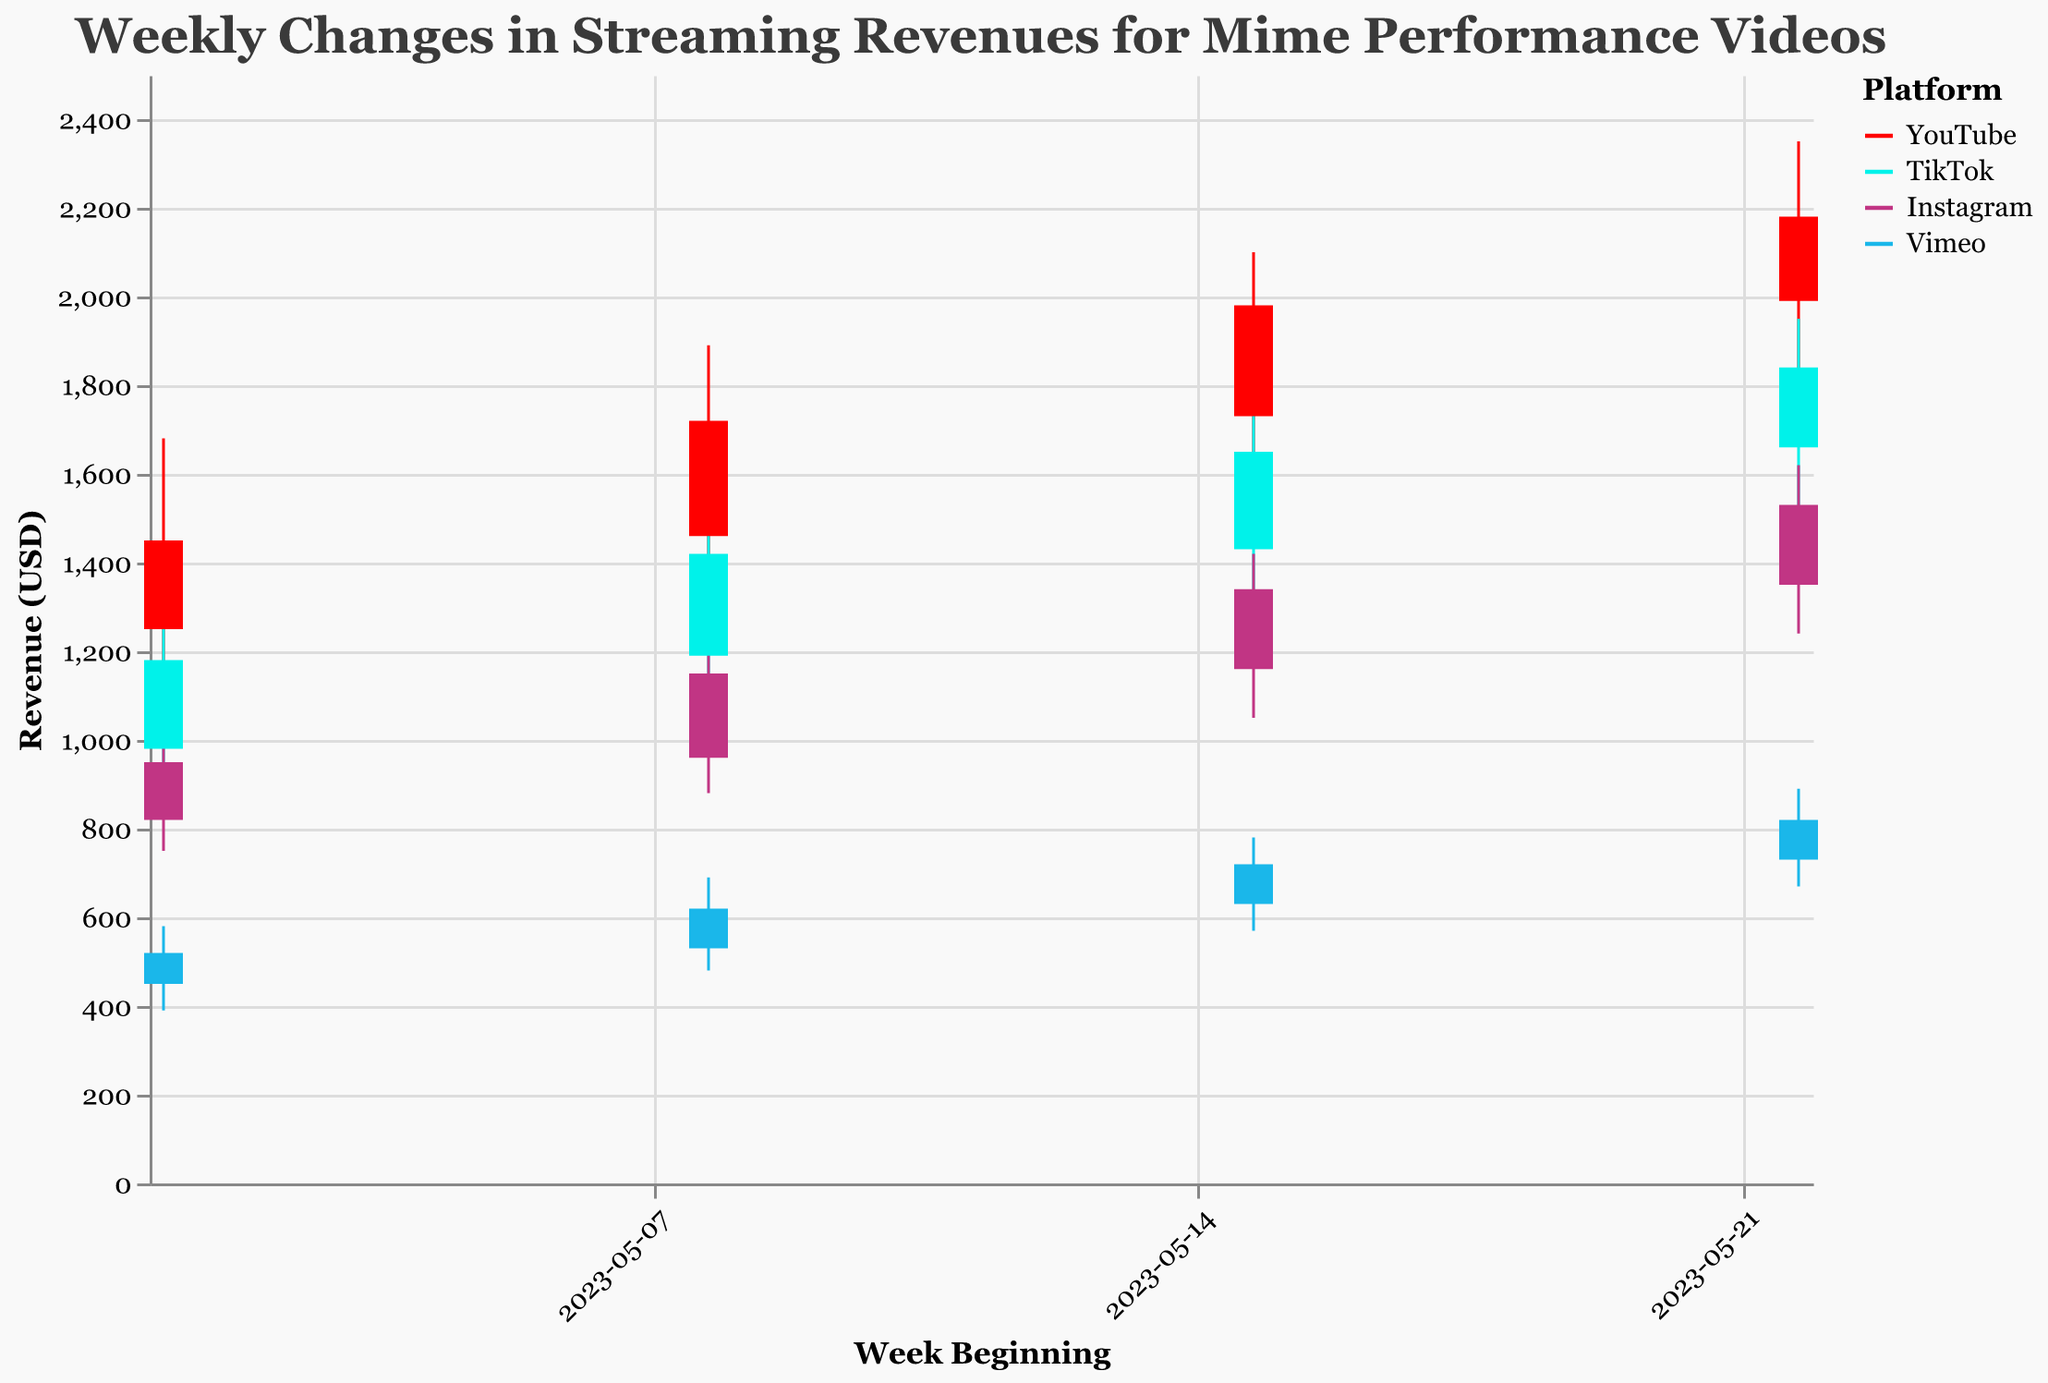What is the title of the chart? The title is displayed at the top center of the chart, indicating the content it represents.
Answer: Weekly Changes in Streaming Revenues for Mime Performance Videos Which platform had the highest revenue on May 22, 2023? Look at the highest points on the bars for May 22, 2023, and identify the corresponding platform color. The revenue of 2350 is the highest, associated with YouTube.
Answer: YouTube What were the opening and closing revenues for Instagram on May 08, 2023? Identify the bar segment for Instagram on May 08, 2023. The bar’s bottom and top correspond to the opening and closing prices respectively. The figures are 960 (Open) and 1150 (Close).
Answer: 960 (Open), 1150 (Close) How did YouTube's revenue range (difference between High and Low) change from May 01 to May 22, 2023? Calculate the range for each week by subtracting the Low value from the High value, and then compare these values over the given dates. May 01: 1680-1120 = 560, May 08: 1890-1350 = 540, May 15: 2100-1590 = 510, May 22: 2350-1820 = 530.
Answer: Decreased from 560 to 530 Did Vimeo ever experience a decrease in weekly closing revenue throughout May 2023? Track the closing revenues for Vimeo each week: May 01 (520), May 08 (620), May 15 (720), May 22 (820). No weekly decrease is observed.
Answer: No Which platform had the smallest difference between opening and closing revenue on May 08, 2023? Calculate the difference (Close - Open) for each platform on the said date: YouTube (1720-1460 = 260), TikTok (1420-1190 = 230), Instagram (1150-960 = 190), Vimeo (620-530 = 90). Vimeo has the smallest difference.
Answer: Vimeo On which date did TikTok have the highest peak revenue? Compare the High values for TikTok across the dates. The highest value for TikTok is 1950 on May 22, 2023.
Answer: May 22, 2023 How did Instagram's closing revenue change from May 01 to May 15, 2023? Compare the closing values for Instagram on the given dates: May 01 (950) and May 15 (1340). Calculate the difference (1340 - 950 = 390).
Answer: Increased by 390 Which week had the largest revenue increase for YouTube from opening to closing values? Calculate the difference (Close - Open) for each week: May 01 (1450-1250 = 200), May 08 (1720-1460 = 260), May 15 (1980-1730 = 250), May 22 (2180-1990 = 190). The largest increase is 260 during the week of May 08.
Answer: Week of May 08 